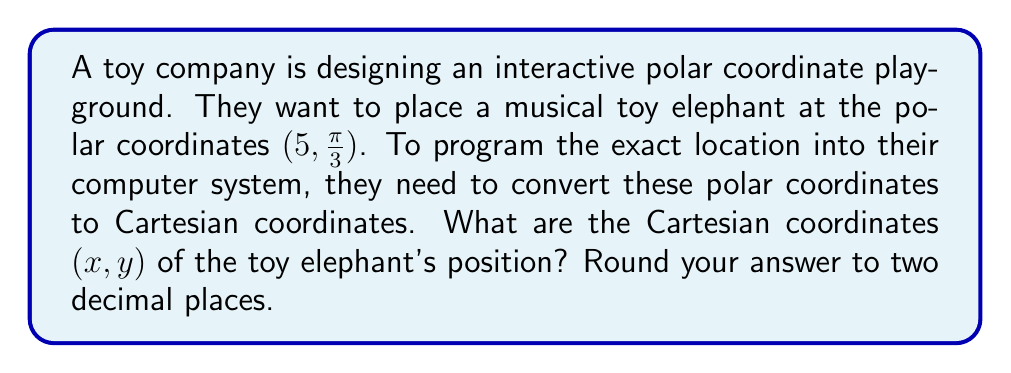Can you solve this math problem? To convert polar coordinates $(r, \theta)$ to Cartesian coordinates $(x, y)$, we use the following formulas:

$$x = r \cos(\theta)$$
$$y = r \sin(\theta)$$

Given:
$r = 5$
$\theta = \frac{\pi}{3}$

Step 1: Calculate x-coordinate
$$x = r \cos(\theta) = 5 \cos(\frac{\pi}{3})$$

$\cos(\frac{\pi}{3}) = \frac{1}{2}$, so:

$$x = 5 \cdot \frac{1}{2} = 2.5$$

Step 2: Calculate y-coordinate
$$y = r \sin(\theta) = 5 \sin(\frac{\pi}{3})$$

$\sin(\frac{\pi}{3}) = \frac{\sqrt{3}}{2}$, so:

$$y = 5 \cdot \frac{\sqrt{3}}{2} = \frac{5\sqrt{3}}{2} \approx 4.33$$

Step 3: Round both coordinates to two decimal places
$x \approx 2.50$
$y \approx 4.33$

Therefore, the Cartesian coordinates of the toy elephant's position are approximately (2.50, 4.33).
Answer: (2.50, 4.33) 